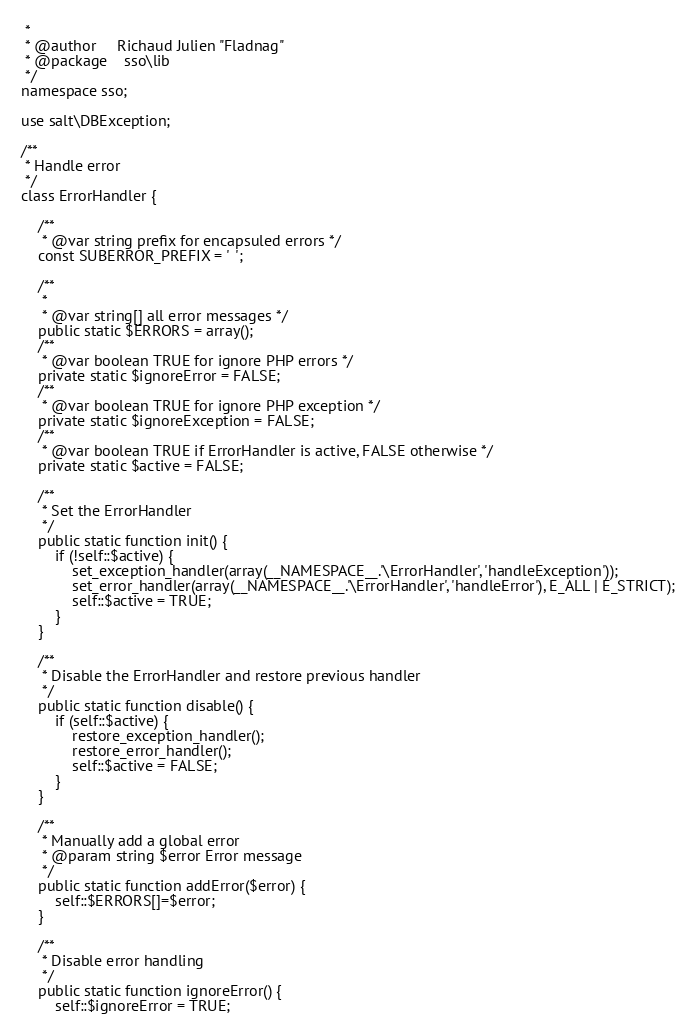<code> <loc_0><loc_0><loc_500><loc_500><_PHP_> *
 * @author     Richaud Julien "Fladnag"
 * @package    sso\lib
 */
namespace sso;

use salt\DBException;

/**
 * Handle error
 */
class ErrorHandler {

	/**
	 * @var string prefix for encapsuled errors */
	const SUBERROR_PREFIX = '  ';

	/**
	 *
	 * @var string[] all error messages */
	public static $ERRORS = array();
	/**
	 * @var boolean TRUE for ignore PHP errors */
	private static $ignoreError = FALSE;
	/**
	 * @var boolean TRUE for ignore PHP exception */
	private static $ignoreException = FALSE;
	/**
	 * @var boolean TRUE if ErrorHandler is active, FALSE otherwise */
	private static $active = FALSE;

	/**
	 * Set the ErrorHandler
	 */
	public static function init() {
		if (!self::$active) {
			set_exception_handler(array(__NAMESPACE__.'\ErrorHandler', 'handleException'));
			set_error_handler(array(__NAMESPACE__.'\ErrorHandler', 'handleError'), E_ALL | E_STRICT);
			self::$active = TRUE;
		}
	}

	/**
	 * Disable the ErrorHandler and restore previous handler
	 */
	public static function disable() {
		if (self::$active) {
			restore_exception_handler();
			restore_error_handler();
			self::$active = FALSE;
		}
	}

	/**
	 * Manually add a global error
	 * @param string $error Error message
	 */
	public static function addError($error) {
		self::$ERRORS[]=$error;
	}

	/**
	 * Disable error handling
	 */
	public static function ignoreError() {
		self::$ignoreError = TRUE;</code> 